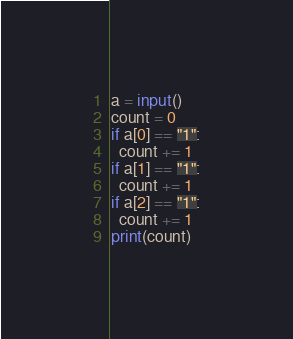Convert code to text. <code><loc_0><loc_0><loc_500><loc_500><_Python_>a = input()
count = 0
if a[0] == "1":
  count += 1
if a[1] == "1":
  count += 1
if a[2] == "1":
  count += 1
print(count)</code> 